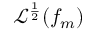<formula> <loc_0><loc_0><loc_500><loc_500>\mathcal { L } ^ { \frac { 1 } { 2 } } ( f _ { m } )</formula> 